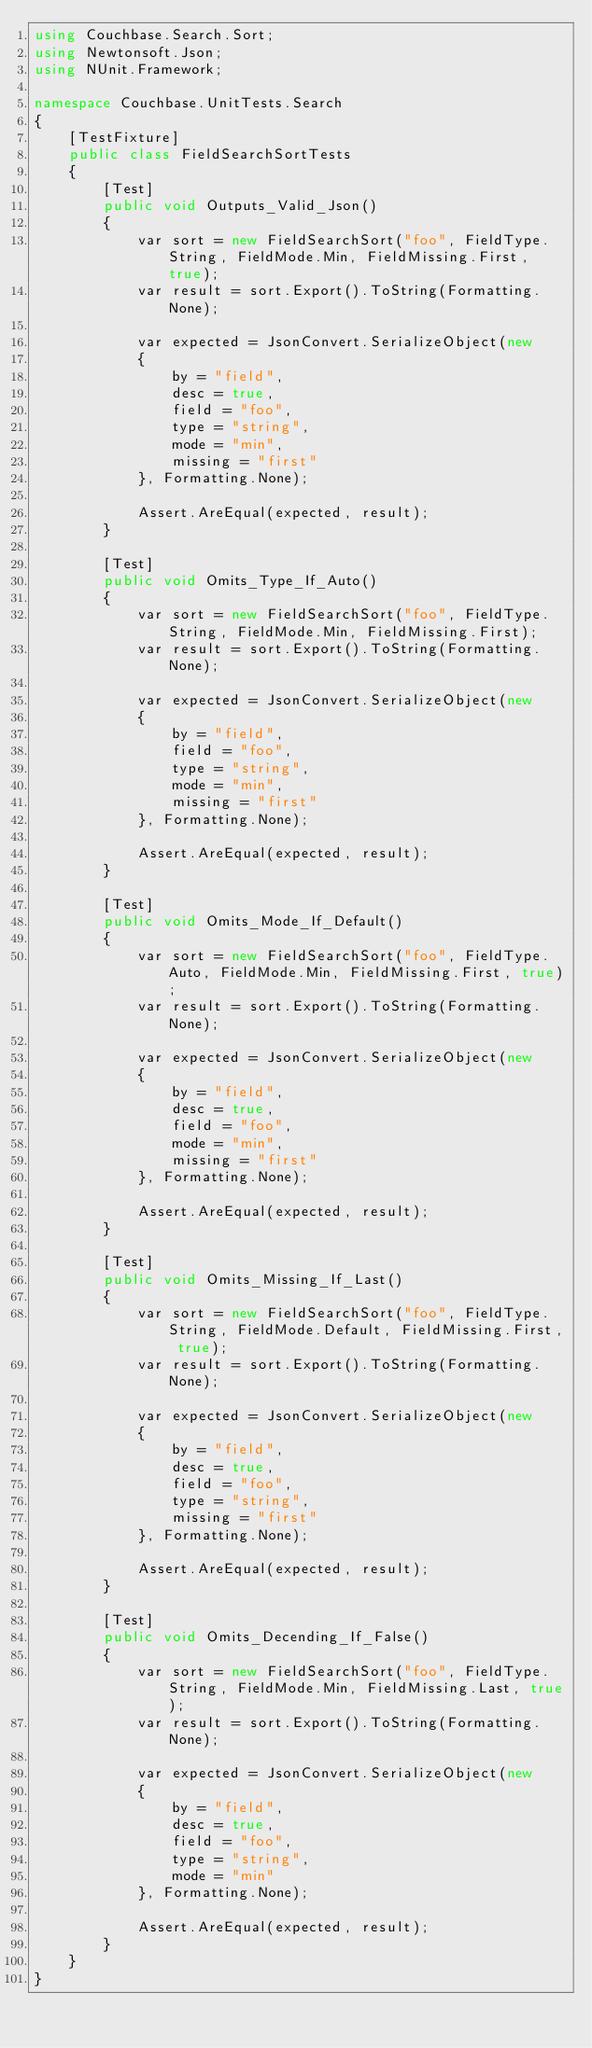Convert code to text. <code><loc_0><loc_0><loc_500><loc_500><_C#_>using Couchbase.Search.Sort;
using Newtonsoft.Json;
using NUnit.Framework;

namespace Couchbase.UnitTests.Search
{
    [TestFixture]
    public class FieldSearchSortTests
    {
        [Test]
        public void Outputs_Valid_Json()
        {
            var sort = new FieldSearchSort("foo", FieldType.String, FieldMode.Min, FieldMissing.First, true);
            var result = sort.Export().ToString(Formatting.None);

            var expected = JsonConvert.SerializeObject(new
            {
                by = "field",
                desc = true,
                field = "foo",
                type = "string",
                mode = "min",
                missing = "first"
            }, Formatting.None);

            Assert.AreEqual(expected, result);
        }

        [Test]
        public void Omits_Type_If_Auto()
        {
            var sort = new FieldSearchSort("foo", FieldType.String, FieldMode.Min, FieldMissing.First);
            var result = sort.Export().ToString(Formatting.None);

            var expected = JsonConvert.SerializeObject(new
            {
                by = "field",
                field = "foo",
                type = "string",
                mode = "min",
                missing = "first"
            }, Formatting.None);

            Assert.AreEqual(expected, result);
        }

        [Test]
        public void Omits_Mode_If_Default()
        {
            var sort = new FieldSearchSort("foo", FieldType.Auto, FieldMode.Min, FieldMissing.First, true);
            var result = sort.Export().ToString(Formatting.None);

            var expected = JsonConvert.SerializeObject(new
            {
                by = "field",
                desc = true,
                field = "foo",
                mode = "min",
                missing = "first"
            }, Formatting.None);

            Assert.AreEqual(expected, result);
        }

        [Test]
        public void Omits_Missing_If_Last()
        {
            var sort = new FieldSearchSort("foo", FieldType.String, FieldMode.Default, FieldMissing.First, true);
            var result = sort.Export().ToString(Formatting.None);

            var expected = JsonConvert.SerializeObject(new
            {
                by = "field",
                desc = true,
                field = "foo",
                type = "string",
                missing = "first"
            }, Formatting.None);

            Assert.AreEqual(expected, result);
        }

        [Test]
        public void Omits_Decending_If_False()
        {
            var sort = new FieldSearchSort("foo", FieldType.String, FieldMode.Min, FieldMissing.Last, true);
            var result = sort.Export().ToString(Formatting.None);

            var expected = JsonConvert.SerializeObject(new
            {
                by = "field",
                desc = true,
                field = "foo",
                type = "string",
                mode = "min"
            }, Formatting.None);

            Assert.AreEqual(expected, result);
        }
    }
}
</code> 